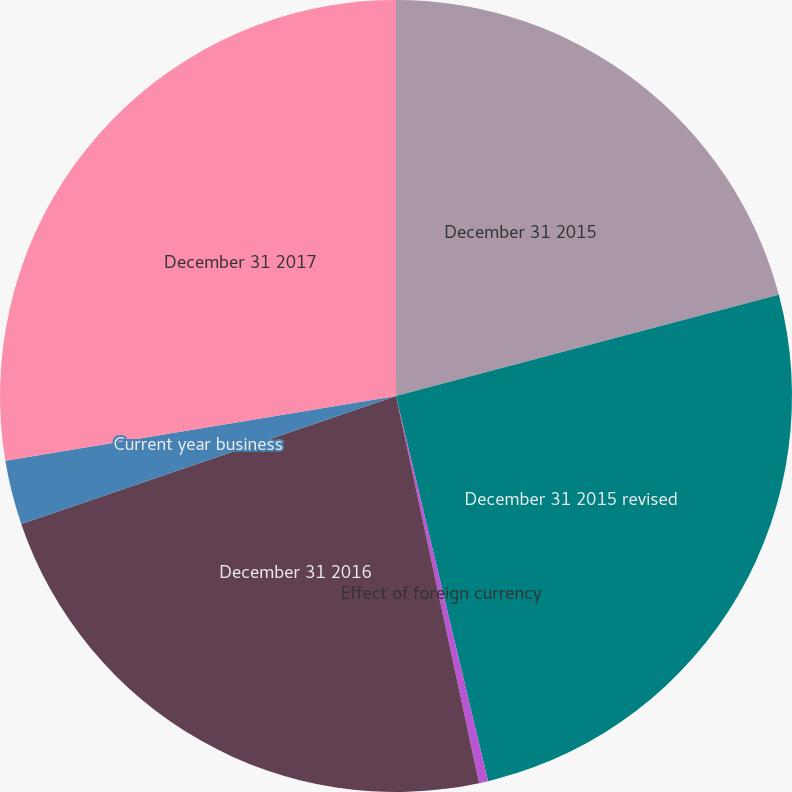<chart> <loc_0><loc_0><loc_500><loc_500><pie_chart><fcel>December 31 2015<fcel>December 31 2015 revised<fcel>Effect of foreign currency<fcel>December 31 2016<fcel>Current year business<fcel>December 31 2017<nl><fcel>20.89%<fcel>25.38%<fcel>0.37%<fcel>23.13%<fcel>2.62%<fcel>27.62%<nl></chart> 